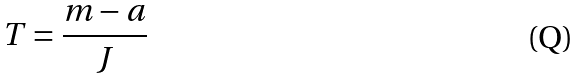Convert formula to latex. <formula><loc_0><loc_0><loc_500><loc_500>T = \frac { m - a } { J }</formula> 